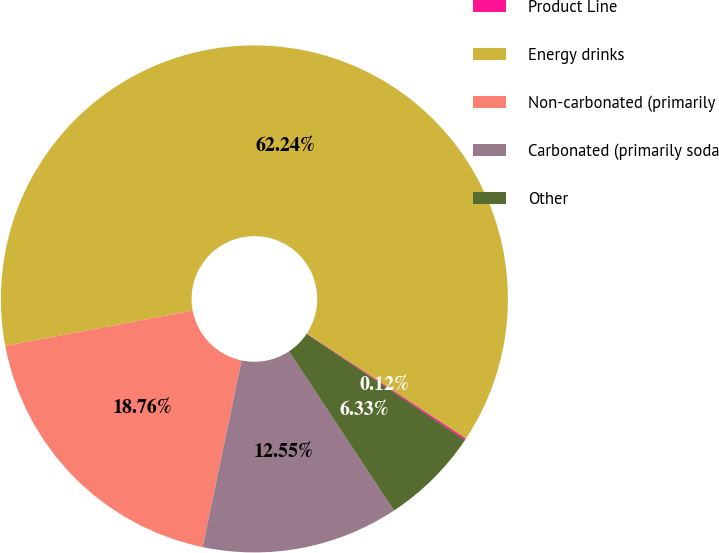Convert chart to OTSL. <chart><loc_0><loc_0><loc_500><loc_500><pie_chart><fcel>Product Line<fcel>Energy drinks<fcel>Non-carbonated (primarily<fcel>Carbonated (primarily soda<fcel>Other<nl><fcel>0.12%<fcel>62.24%<fcel>18.76%<fcel>12.55%<fcel>6.33%<nl></chart> 